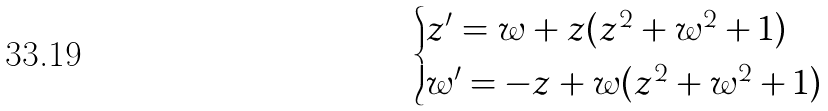Convert formula to latex. <formula><loc_0><loc_0><loc_500><loc_500>\begin{cases} z ^ { \prime } = w + z ( z ^ { 2 } + w ^ { 2 } + 1 ) \\ w ^ { \prime } = - z + w ( z ^ { 2 } + w ^ { 2 } + 1 ) \end{cases}</formula> 